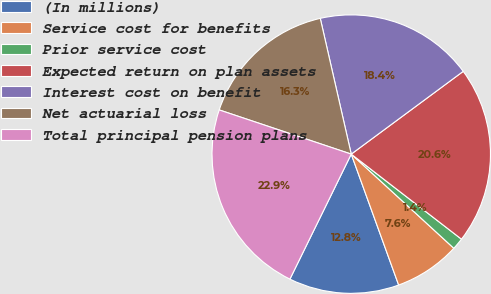<chart> <loc_0><loc_0><loc_500><loc_500><pie_chart><fcel>(In millions)<fcel>Service cost for benefits<fcel>Prior service cost<fcel>Expected return on plan assets<fcel>Interest cost on benefit<fcel>Net actuarial loss<fcel>Total principal pension plans<nl><fcel>12.79%<fcel>7.65%<fcel>1.36%<fcel>20.59%<fcel>18.44%<fcel>16.29%<fcel>22.88%<nl></chart> 